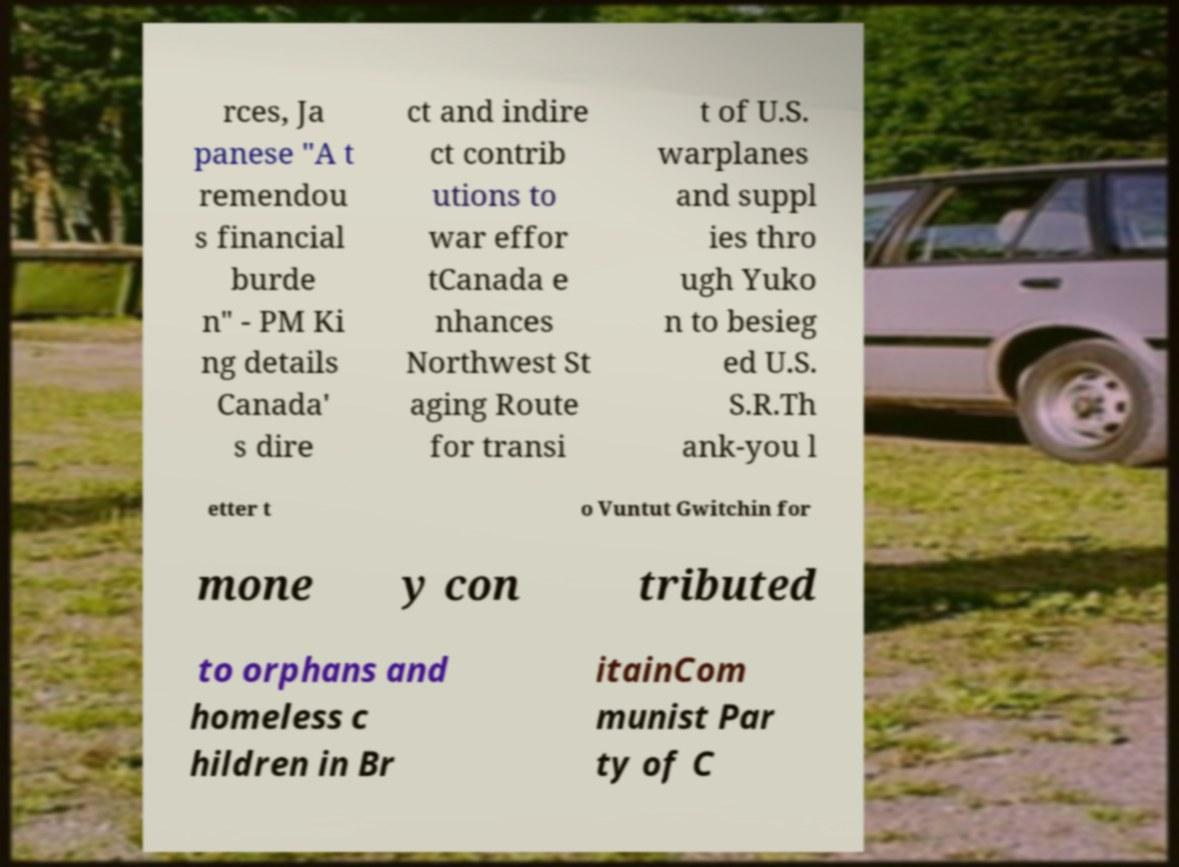For documentation purposes, I need the text within this image transcribed. Could you provide that? rces, Ja panese "A t remendou s financial burde n" - PM Ki ng details Canada' s dire ct and indire ct contrib utions to war effor tCanada e nhances Northwest St aging Route for transi t of U.S. warplanes and suppl ies thro ugh Yuko n to besieg ed U.S. S.R.Th ank-you l etter t o Vuntut Gwitchin for mone y con tributed to orphans and homeless c hildren in Br itainCom munist Par ty of C 